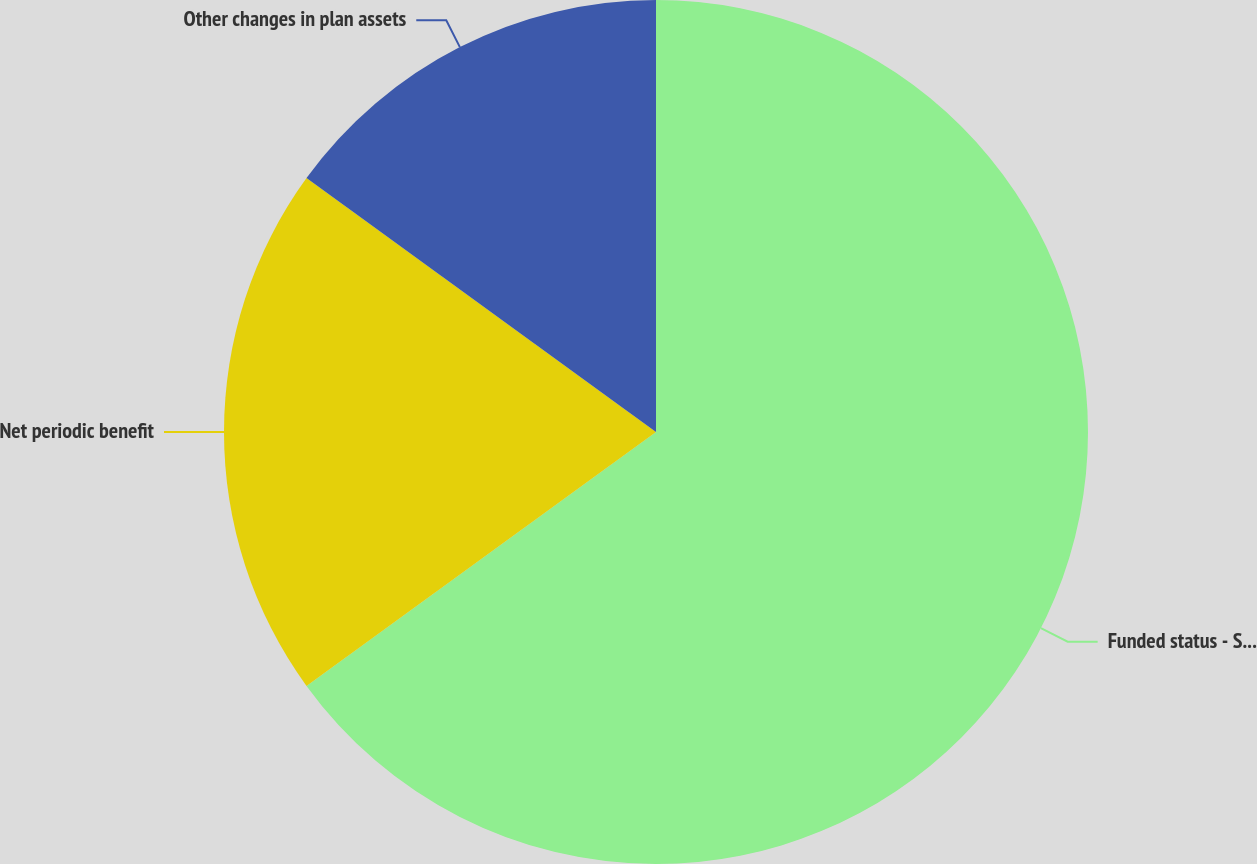Convert chart to OTSL. <chart><loc_0><loc_0><loc_500><loc_500><pie_chart><fcel>Funded status - STPNOC benefit<fcel>Net periodic benefit<fcel>Other changes in plan assets<nl><fcel>65.0%<fcel>20.0%<fcel>15.0%<nl></chart> 